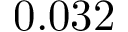Convert formula to latex. <formula><loc_0><loc_0><loc_500><loc_500>0 . 0 3 2</formula> 